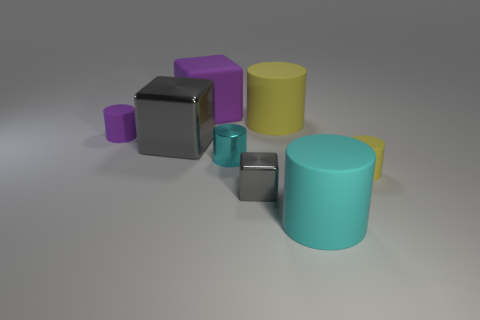Is the number of small objects behind the large metal block less than the number of large yellow things that are left of the small gray shiny object?
Offer a terse response. No. Do the tiny purple object that is behind the large shiny cube and the large cyan rubber object have the same shape?
Your answer should be compact. Yes. Are the purple thing that is to the right of the large gray cube and the small yellow cylinder made of the same material?
Give a very brief answer. Yes. What material is the gray cube behind the gray shiny block that is in front of the yellow cylinder right of the cyan matte thing?
Your response must be concise. Metal. How many other objects are there of the same shape as the small purple object?
Ensure brevity in your answer.  4. There is a big block that is behind the purple cylinder; what color is it?
Ensure brevity in your answer.  Purple. What number of purple matte things are behind the gray metallic cube in front of the small rubber cylinder that is right of the small block?
Keep it short and to the point. 2. There is a small cylinder that is behind the cyan metallic object; what number of large cyan matte objects are behind it?
Your answer should be compact. 0. How many tiny matte things are on the left side of the big purple rubber object?
Provide a short and direct response. 1. How many other objects are there of the same size as the rubber cube?
Your answer should be very brief. 3. 